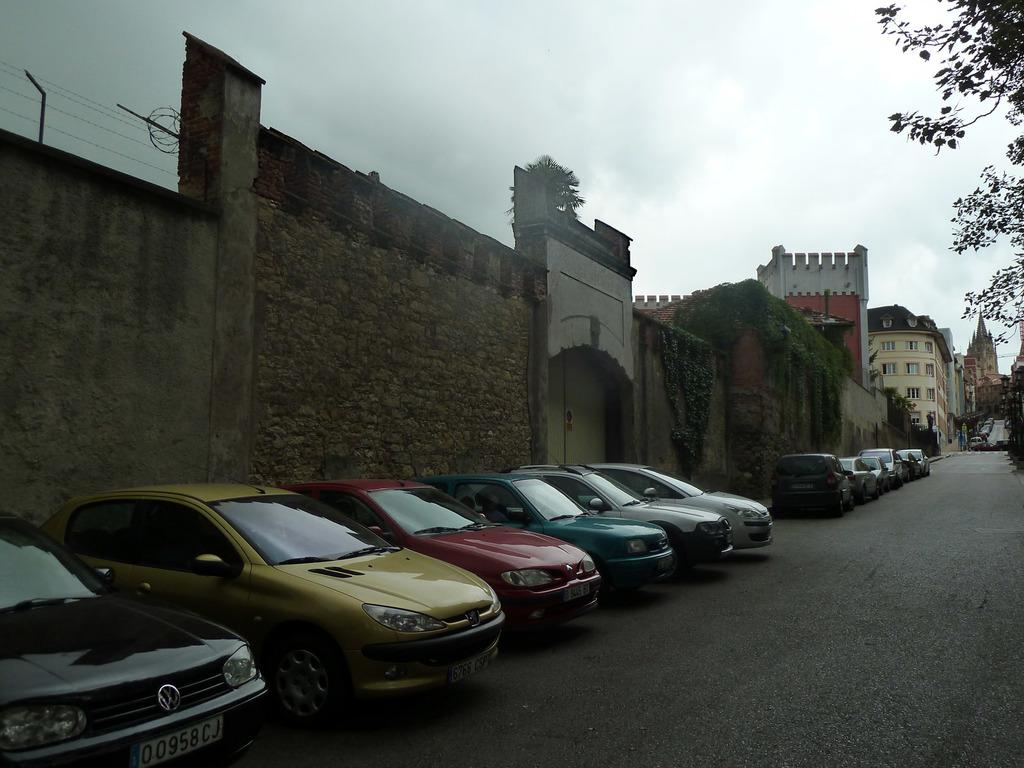What can be seen parked in the image? There are cars parked in the image. What type of structures are visible in the image? There are buildings visible in the image. What type of vegetation is present in the image? There are trees in the image. What type of barrier is present in the image? There is a wall in the image. What is the condition of the sky in the image? The sky is cloudy in the image. Can you tell me which ear is visible in the image? There are no ears present in the image; it features cars, buildings, trees, a wall, and a cloudy sky. What type of art can be seen hanging on the wall in the image? There is no art visible on the wall in the image. 